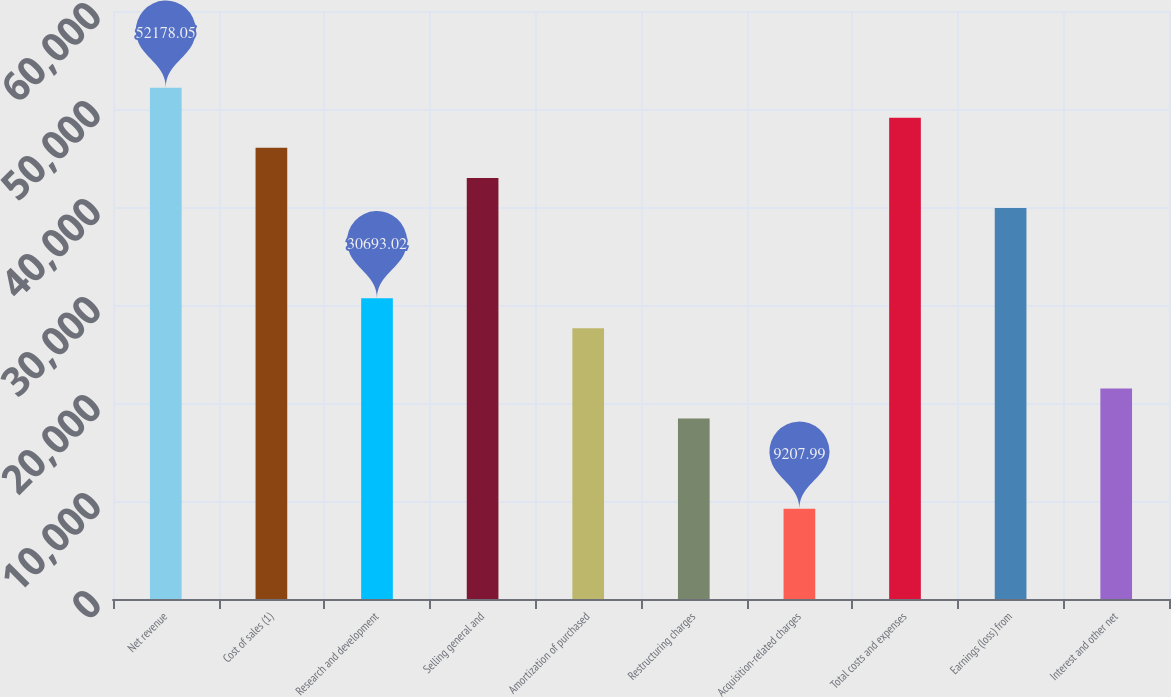<chart> <loc_0><loc_0><loc_500><loc_500><bar_chart><fcel>Net revenue<fcel>Cost of sales (1)<fcel>Research and development<fcel>Selling general and<fcel>Amortization of purchased<fcel>Restructuring charges<fcel>Acquisition-related charges<fcel>Total costs and expenses<fcel>Earnings (loss) from<fcel>Interest and other net<nl><fcel>52178.1<fcel>46039.5<fcel>30693<fcel>42970.2<fcel>27623.7<fcel>18415.9<fcel>9207.99<fcel>49108.8<fcel>39900.9<fcel>21485.2<nl></chart> 